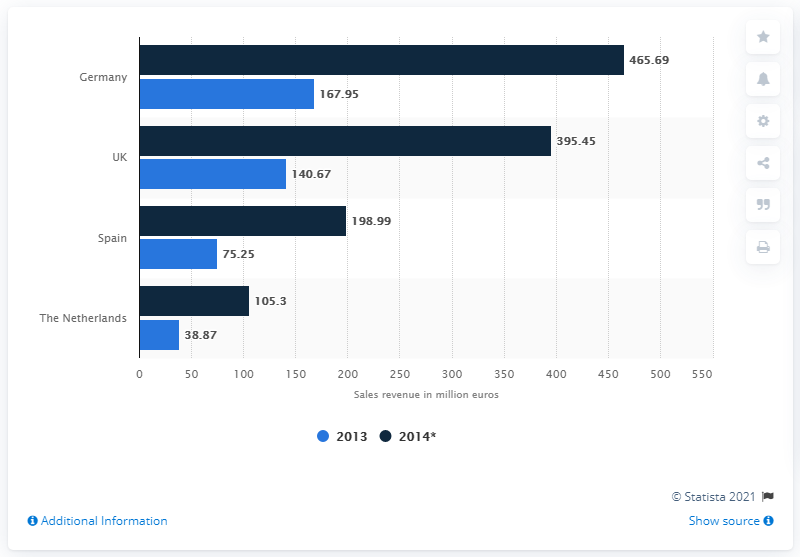Point out several critical features in this image. In 2013, the sales revenue of wearable technology devices in the UK was 140.67. The expected value of the wearables market in the UK in 2014 was 395.45. The average sales revenue in the Netherlands is 72,085. Germany has the highest sales revenue among all countries. 